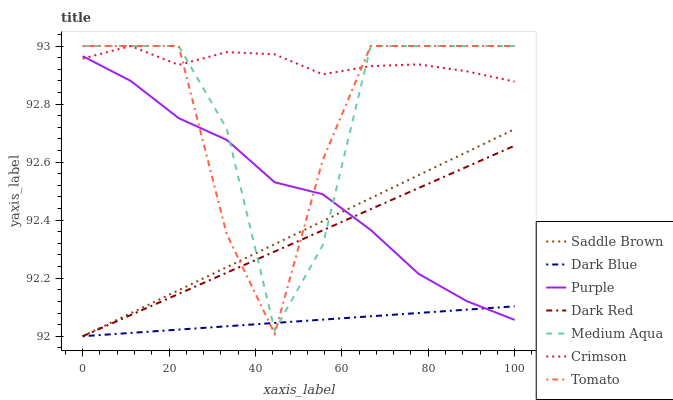Does Dark Blue have the minimum area under the curve?
Answer yes or no. Yes. Does Crimson have the maximum area under the curve?
Answer yes or no. Yes. Does Purple have the minimum area under the curve?
Answer yes or no. No. Does Purple have the maximum area under the curve?
Answer yes or no. No. Is Dark Blue the smoothest?
Answer yes or no. Yes. Is Medium Aqua the roughest?
Answer yes or no. Yes. Is Purple the smoothest?
Answer yes or no. No. Is Purple the roughest?
Answer yes or no. No. Does Purple have the lowest value?
Answer yes or no. No. Does Crimson have the highest value?
Answer yes or no. Yes. Does Purple have the highest value?
Answer yes or no. No. Is Saddle Brown less than Crimson?
Answer yes or no. Yes. Is Crimson greater than Dark Red?
Answer yes or no. Yes. Does Dark Blue intersect Medium Aqua?
Answer yes or no. Yes. Is Dark Blue less than Medium Aqua?
Answer yes or no. No. Is Dark Blue greater than Medium Aqua?
Answer yes or no. No. Does Saddle Brown intersect Crimson?
Answer yes or no. No. 